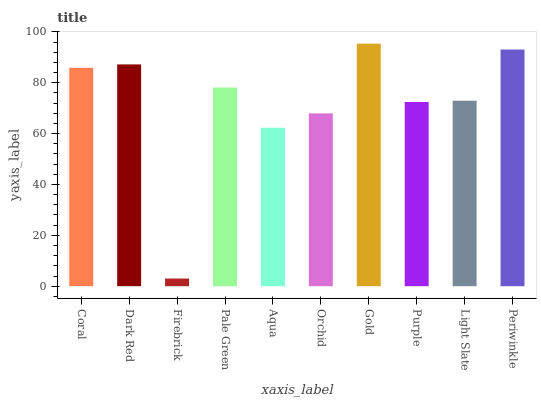Is Firebrick the minimum?
Answer yes or no. Yes. Is Gold the maximum?
Answer yes or no. Yes. Is Dark Red the minimum?
Answer yes or no. No. Is Dark Red the maximum?
Answer yes or no. No. Is Dark Red greater than Coral?
Answer yes or no. Yes. Is Coral less than Dark Red?
Answer yes or no. Yes. Is Coral greater than Dark Red?
Answer yes or no. No. Is Dark Red less than Coral?
Answer yes or no. No. Is Pale Green the high median?
Answer yes or no. Yes. Is Light Slate the low median?
Answer yes or no. Yes. Is Light Slate the high median?
Answer yes or no. No. Is Pale Green the low median?
Answer yes or no. No. 